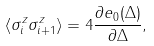Convert formula to latex. <formula><loc_0><loc_0><loc_500><loc_500>\langle \sigma _ { i } ^ { z } \sigma _ { i + 1 } ^ { z } \rangle = 4 \frac { \partial e _ { 0 } ( \Delta ) } { \partial \Delta } ,</formula> 